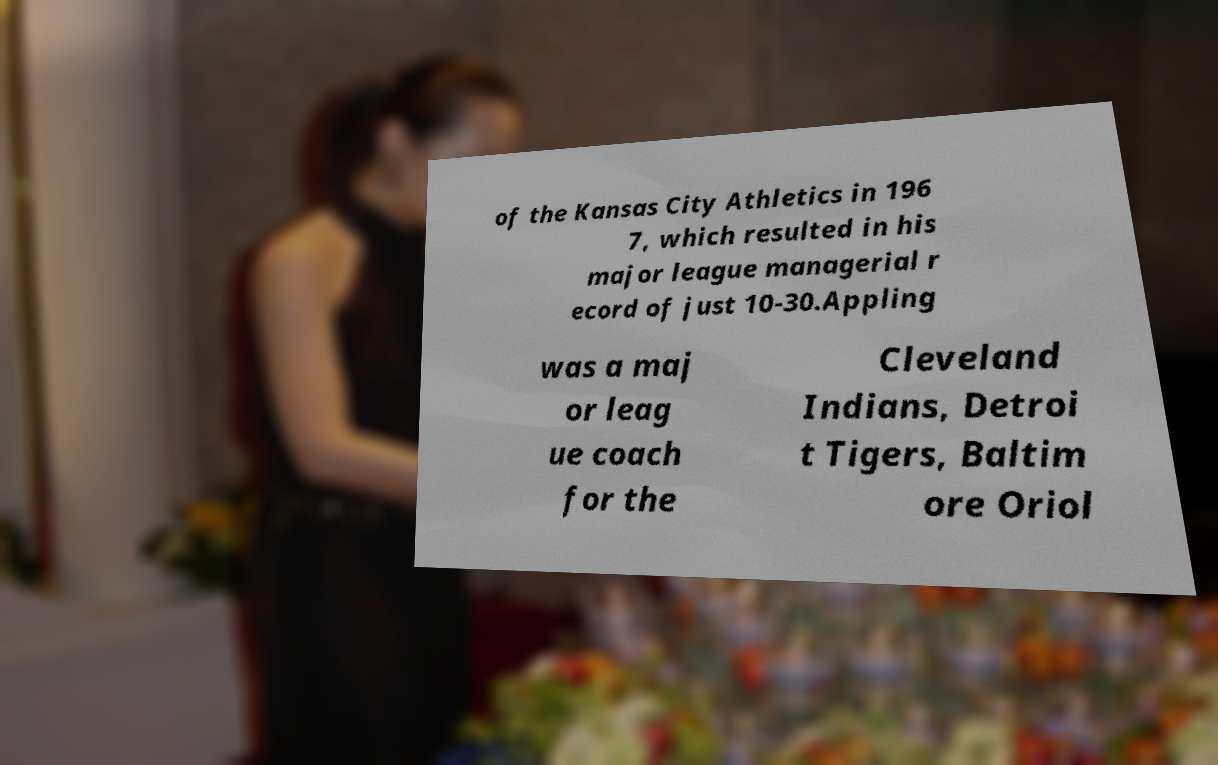What messages or text are displayed in this image? I need them in a readable, typed format. of the Kansas City Athletics in 196 7, which resulted in his major league managerial r ecord of just 10-30.Appling was a maj or leag ue coach for the Cleveland Indians, Detroi t Tigers, Baltim ore Oriol 